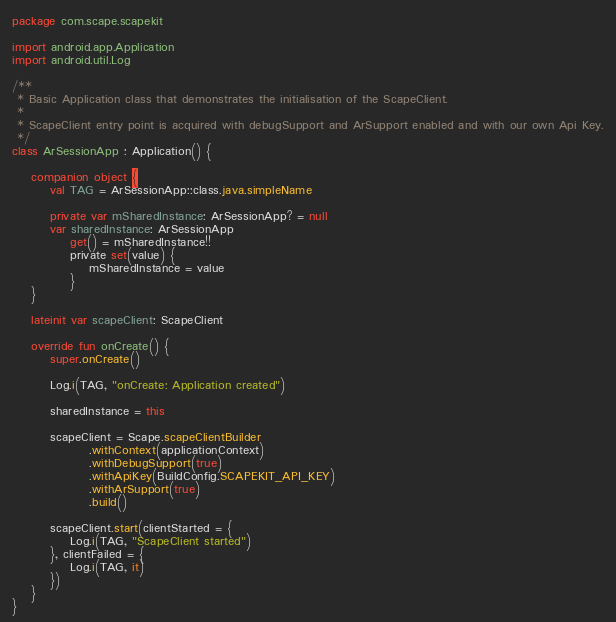<code> <loc_0><loc_0><loc_500><loc_500><_Kotlin_>package com.scape.scapekit

import android.app.Application
import android.util.Log

/**
 * Basic Application class that demonstrates the initialisation of the ScapeClient.
 *
 * ScapeClient entry point is acquired with debugSupport and ArSupport enabled and with our own Api Key.
 */
class ArSessionApp : Application() {

    companion object {
        val TAG = ArSessionApp::class.java.simpleName

        private var mSharedInstance: ArSessionApp? = null
        var sharedInstance: ArSessionApp
            get() = mSharedInstance!!
            private set(value) {
                mSharedInstance = value
            }
    }

    lateinit var scapeClient: ScapeClient

    override fun onCreate() {
        super.onCreate()

        Log.i(TAG, "onCreate: Application created")

        sharedInstance = this

        scapeClient = Scape.scapeClientBuilder
                .withContext(applicationContext)
                .withDebugSupport(true)
                .withApiKey(BuildConfig.SCAPEKIT_API_KEY)
                .withArSupport(true)
                .build()

        scapeClient.start(clientStarted = {
            Log.i(TAG, "ScapeClient started")
        }, clientFailed = {
            Log.i(TAG, it)
        })
    }
}</code> 